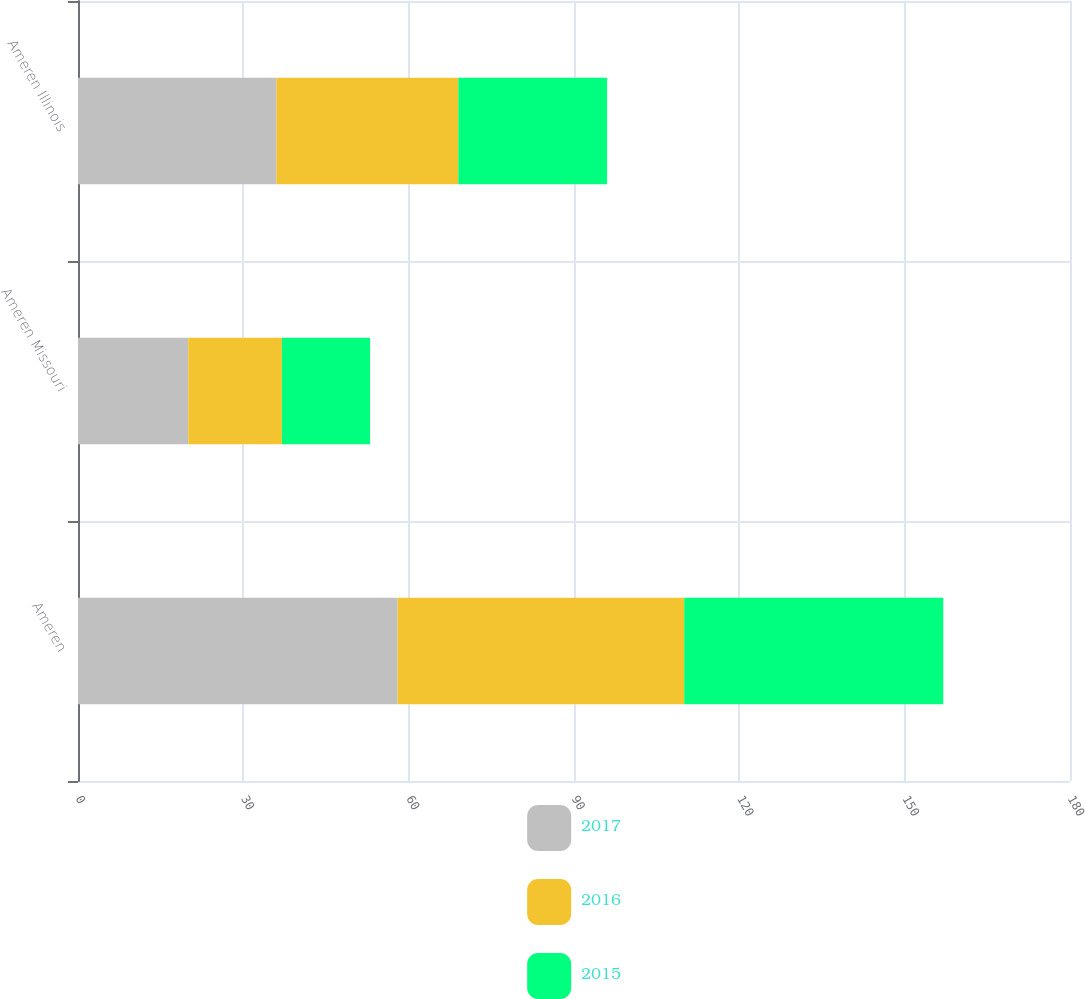Convert chart to OTSL. <chart><loc_0><loc_0><loc_500><loc_500><stacked_bar_chart><ecel><fcel>Ameren<fcel>Ameren Missouri<fcel>Ameren Illinois<nl><fcel>2017<fcel>58<fcel>20<fcel>36<nl><fcel>2016<fcel>52<fcel>17<fcel>33<nl><fcel>2015<fcel>47<fcel>16<fcel>27<nl></chart> 